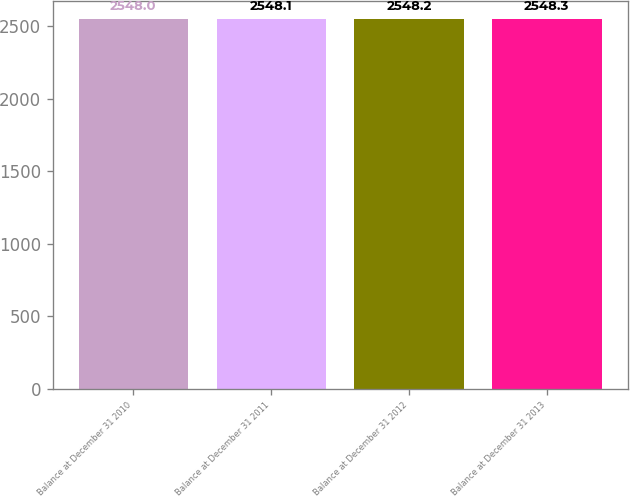Convert chart to OTSL. <chart><loc_0><loc_0><loc_500><loc_500><bar_chart><fcel>Balance at December 31 2010<fcel>Balance at December 31 2011<fcel>Balance at December 31 2012<fcel>Balance at December 31 2013<nl><fcel>2548<fcel>2548.1<fcel>2548.2<fcel>2548.3<nl></chart> 